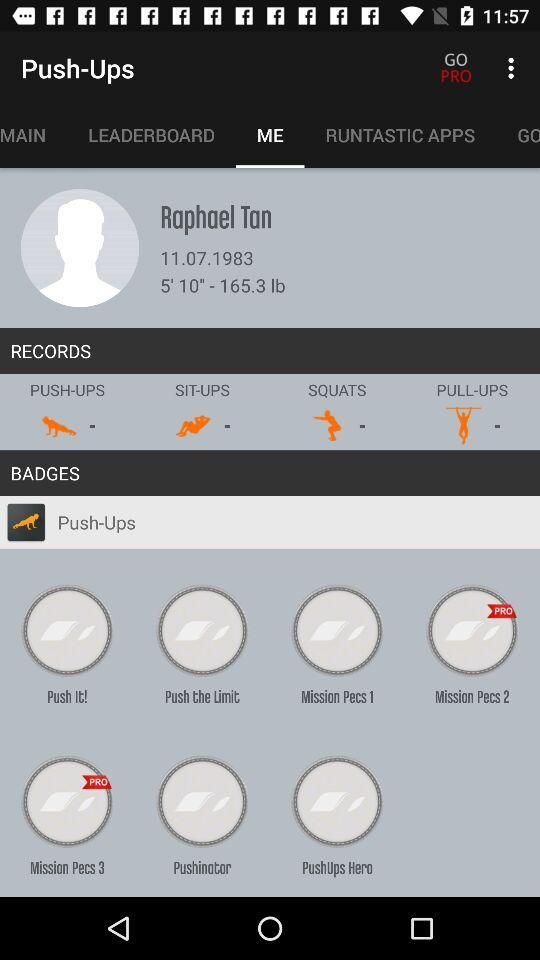Which "RUNTASTIC APPS" are available?
When the provided information is insufficient, respond with <no answer>. <no answer> 